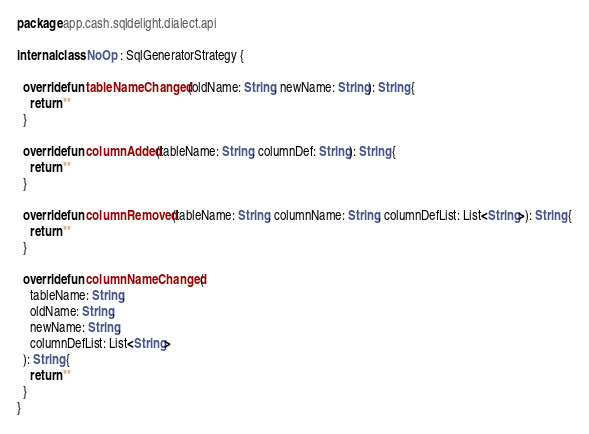Convert code to text. <code><loc_0><loc_0><loc_500><loc_500><_Kotlin_>package app.cash.sqldelight.dialect.api

internal class NoOp : SqlGeneratorStrategy {

  override fun tableNameChanged(oldName: String, newName: String): String {
    return ""
  }

  override fun columnAdded(tableName: String, columnDef: String): String {
    return ""
  }

  override fun columnRemoved(tableName: String, columnName: String, columnDefList: List<String>): String {
    return ""
  }

  override fun columnNameChanged(
    tableName: String,
    oldName: String,
    newName: String,
    columnDefList: List<String>
  ): String {
    return ""
  }
}
</code> 